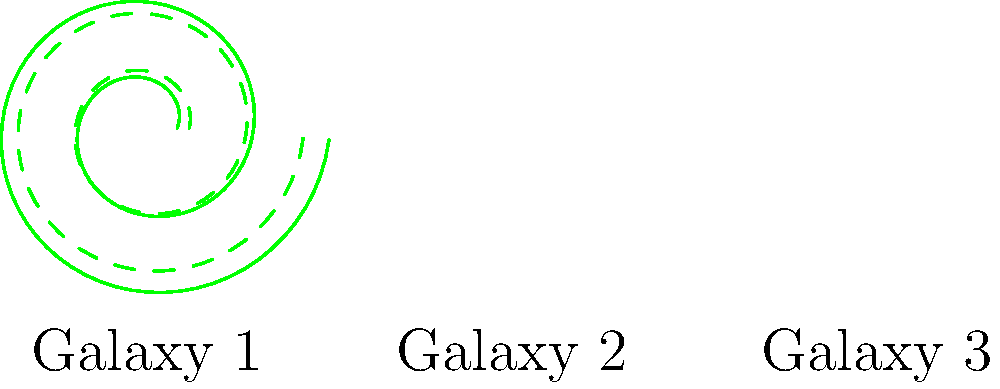Examine the spiral arm structures of the three galaxies shown. Which pair of galaxies have congruent spiral arms? Explain your reasoning based on the mathematical properties of the spiral structures. To determine which pair of galaxies have congruent spiral arms, we need to analyze the mathematical properties of the spiral structures:

1. Galaxy 1: Both spiral arms are identical, represented by the same equation $r = a + bt$, where $a$ and $b$ are constants and $t$ is the angle.

2. Galaxy 2: The spiral arms are identical to those in Galaxy 1, but one arm is rotated 45° relative to the other. The rotation doesn't affect the underlying structure, so the arms remain congruent.

3. Galaxy 3: One spiral arm is similar to those in Galaxies 1 and 2, but the second arm (dashed line) has a different equation. It appears to have a larger initial radius ($a$) and a smaller rate of expansion ($b$).

To be congruent, spiral arms must have the same shape and size, which means they must be described by the same equation with identical parameters.

Galaxies 1 and 2 have identical spiral arm structures, differing only in orientation. Their arms are described by the same equation with the same parameters, making them congruent.

Galaxy 3, however, has one arm that differs in its mathematical description, making it non-congruent with the other galaxies.

Therefore, Galaxies 1 and 2 have congruent spiral arms.
Answer: Galaxies 1 and 2 